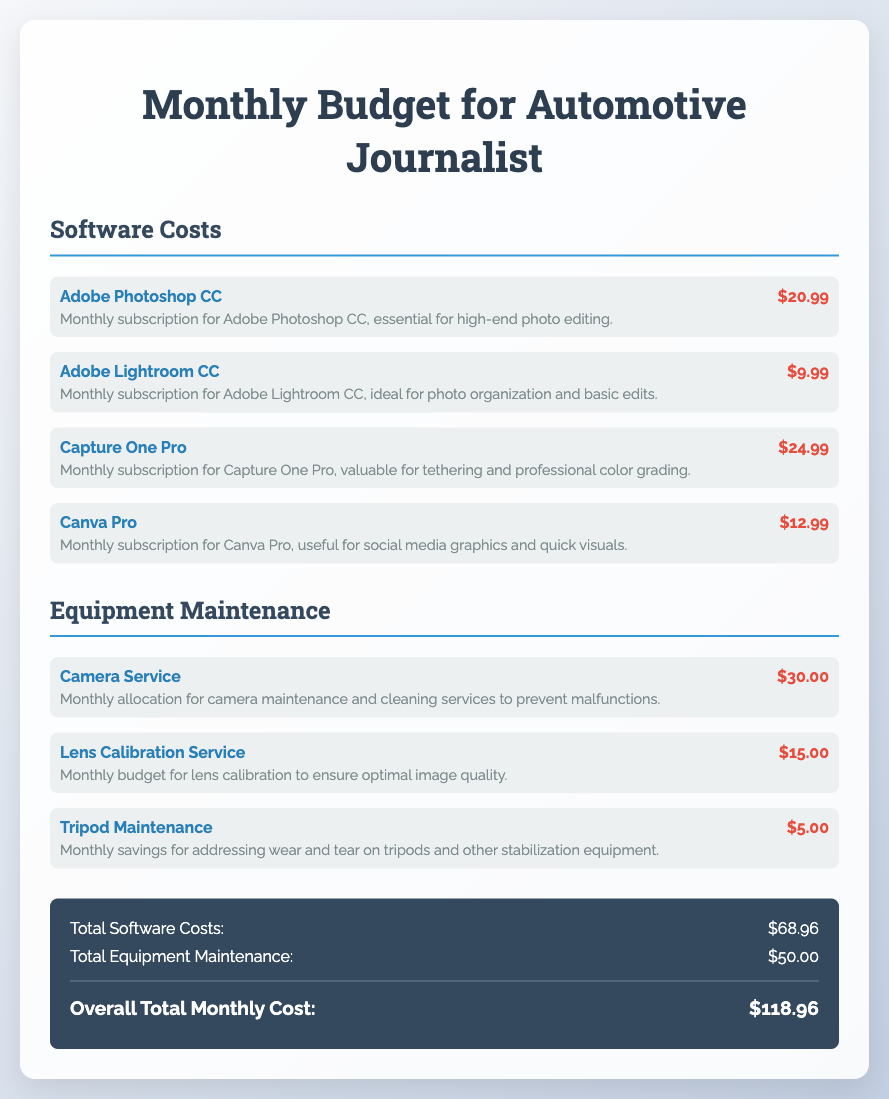What is the total cost for Adobe Photoshop CC? The total cost for Adobe Photoshop CC is listed in the software costs section as $20.99.
Answer: $20.99 What is the expense for lens calibration service? The expense for lens calibration service is detailed in the equipment maintenance section and amounts to $15.00.
Answer: $15.00 What is the overall total monthly cost? The overall total monthly cost is provided at the end of the budget as $118.96.
Answer: $118.96 How much is allocated for tripod maintenance? The allocation for tripod maintenance is specified in the equipment maintenance section as $5.00.
Answer: $5.00 What is the total for software costs? The total for software costs is the sum of all individual software expenses, which amounts to $68.96.
Answer: $68.96 Which software is intended for social media graphics? The software intended for social media graphics is Canva Pro, as mentioned in the software costs section.
Answer: Canva Pro How much do you pay for Adobe Lightroom CC? The payment for Adobe Lightroom CC is indicated as $9.99 in the software costs list.
Answer: $9.99 What is the monthly budget for camera service? The monthly budget for camera service is allocated at $30.00 according to the equipment maintenance section.
Answer: $30.00 